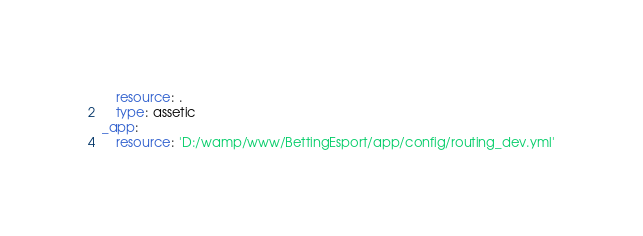<code> <loc_0><loc_0><loc_500><loc_500><_YAML_>    resource: .
    type: assetic
_app:
    resource: 'D:/wamp/www/BettingEsport/app/config/routing_dev.yml'
</code> 